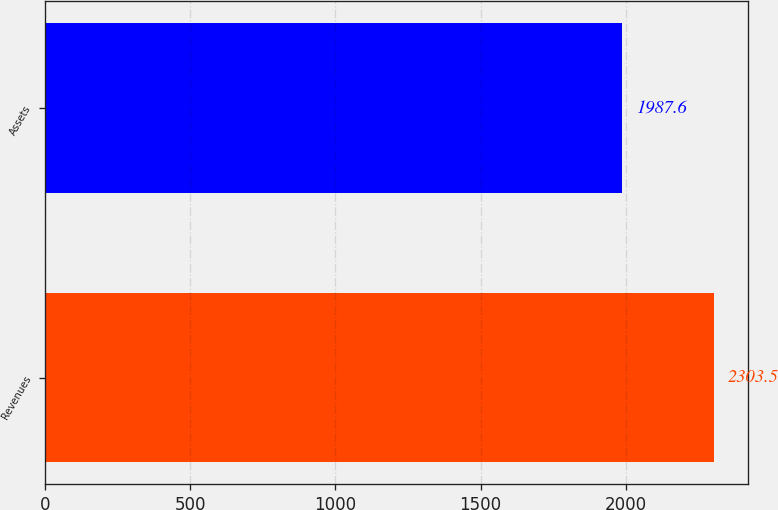Convert chart. <chart><loc_0><loc_0><loc_500><loc_500><bar_chart><fcel>Revenues<fcel>Assets<nl><fcel>2303.5<fcel>1987.6<nl></chart> 